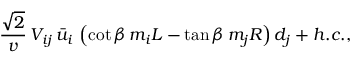Convert formula to latex. <formula><loc_0><loc_0><loc_500><loc_500>\frac { \sqrt { 2 } } { v } \, V _ { i j } \, \bar { u } _ { i } \, \left ( \cot \beta \, m _ { i } L - \tan \beta \, m _ { j } R \right ) d _ { j } + h . c . ,</formula> 